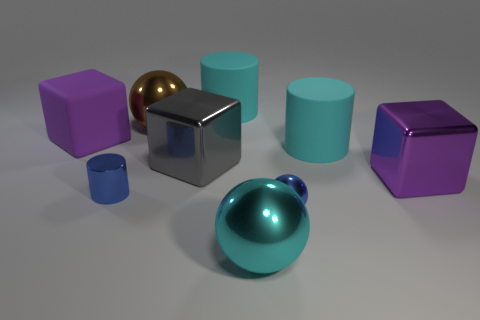Is the material of the big gray object the same as the big cyan thing that is behind the big purple matte thing?
Your answer should be compact. No. What size is the blue metal cylinder in front of the object that is to the left of the blue metallic thing behind the blue sphere?
Your answer should be compact. Small. What material is the ball that is behind the blue shiny ball right of the gray cube?
Your response must be concise. Metal. Is there another big thing that has the same shape as the big gray shiny object?
Your answer should be compact. Yes. The large brown thing is what shape?
Provide a succinct answer. Sphere. What is the material of the large object that is on the left side of the large metal sphere left of the cyan rubber thing that is behind the purple matte object?
Your response must be concise. Rubber. Is the number of objects behind the blue metal sphere greater than the number of large brown metal cylinders?
Ensure brevity in your answer.  Yes. There is another purple cube that is the same size as the purple shiny cube; what material is it?
Give a very brief answer. Rubber. Are there any cylinders of the same size as the brown ball?
Your answer should be compact. Yes. There is a cyan metallic sphere on the right side of the gray metal cube; what size is it?
Make the answer very short. Large. 